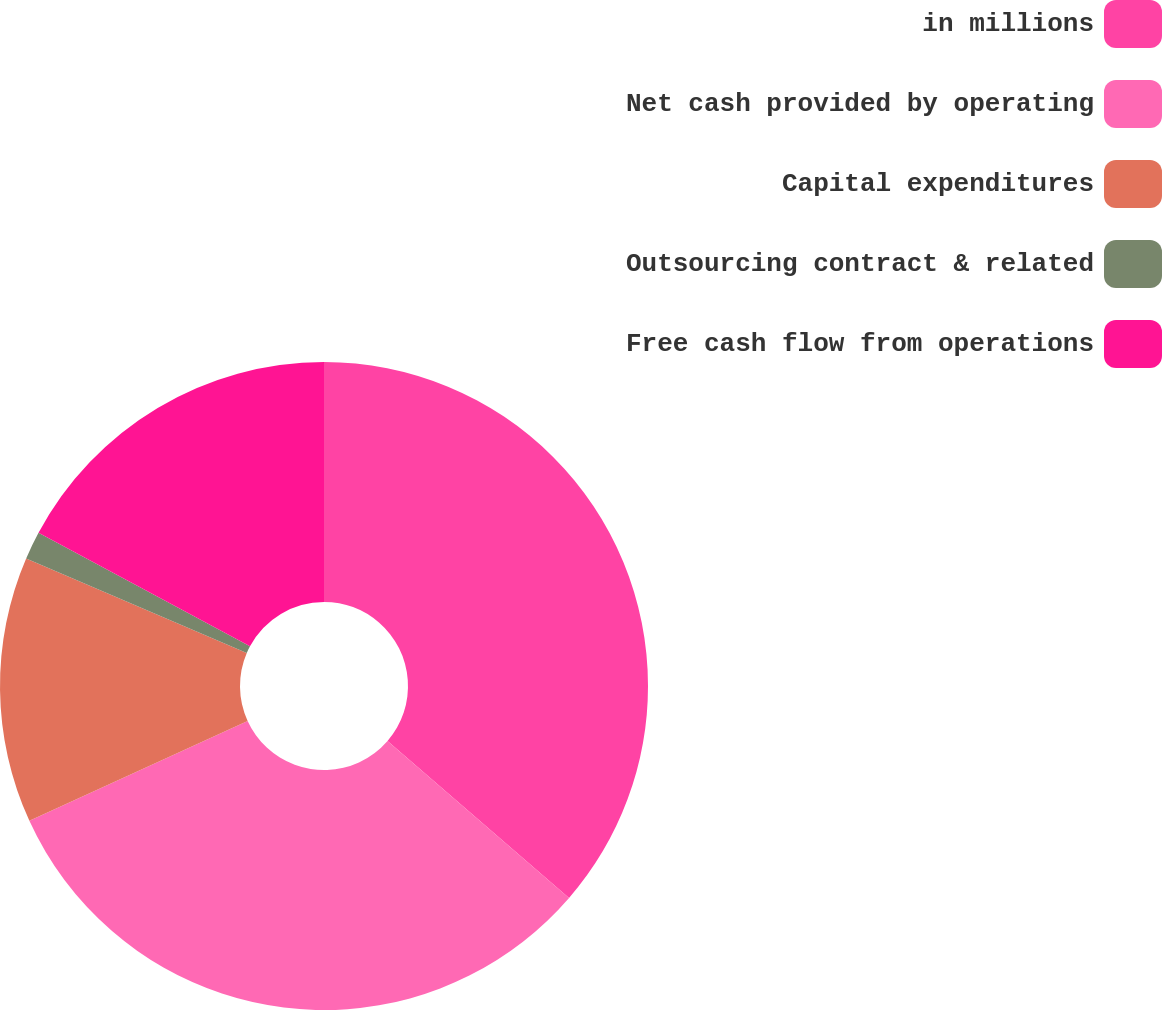Convert chart to OTSL. <chart><loc_0><loc_0><loc_500><loc_500><pie_chart><fcel>in millions<fcel>Net cash provided by operating<fcel>Capital expenditures<fcel>Outsourcing contract & related<fcel>Free cash flow from operations<nl><fcel>36.35%<fcel>31.82%<fcel>13.27%<fcel>1.4%<fcel>17.16%<nl></chart> 